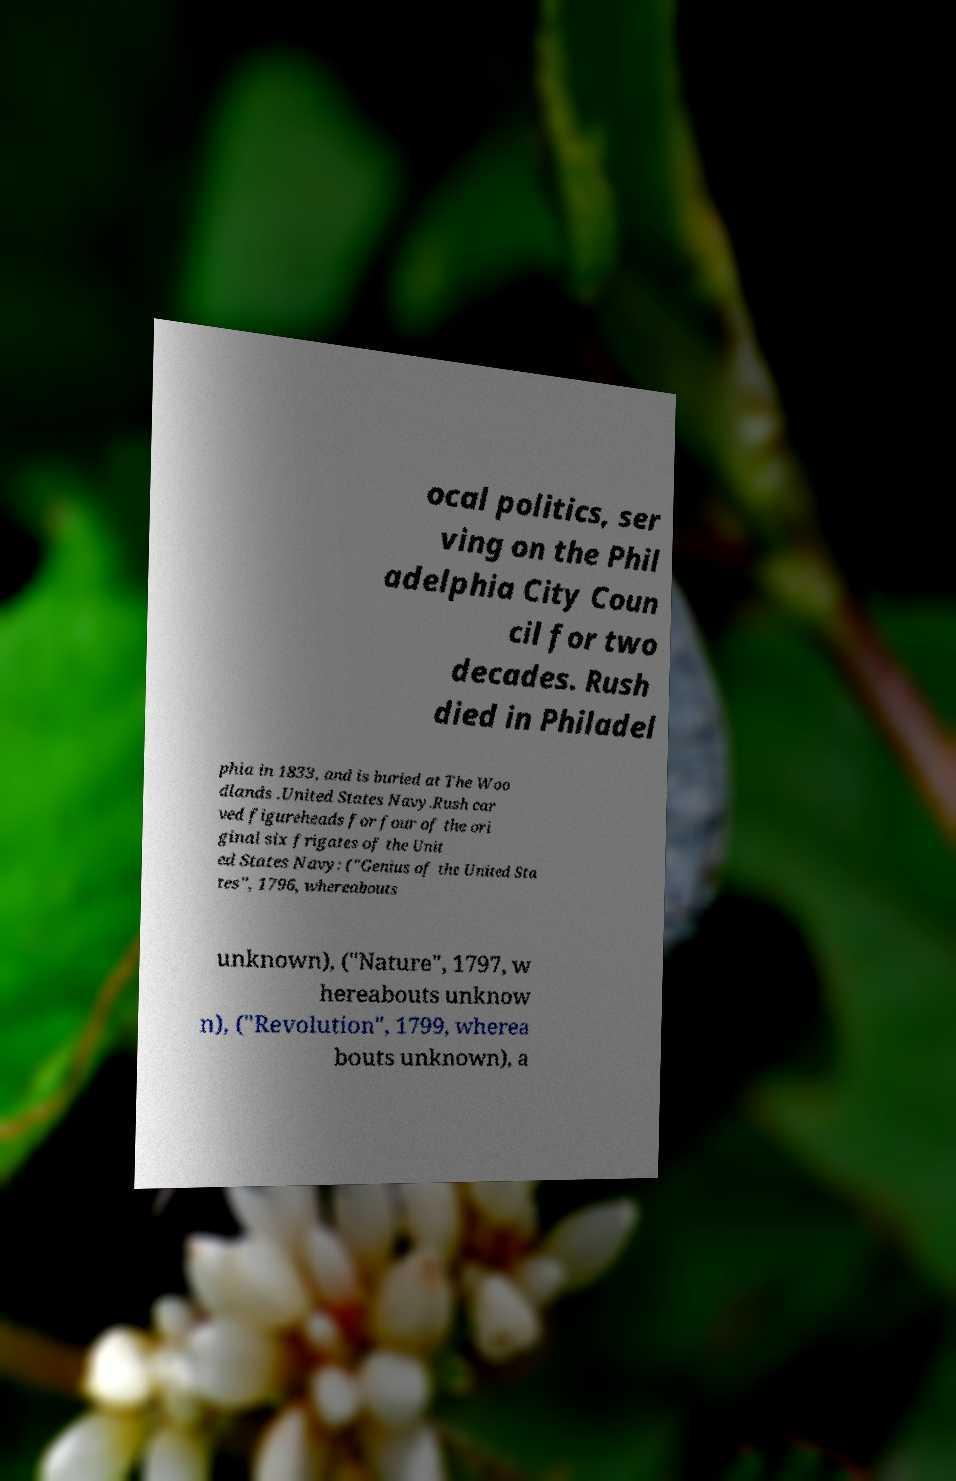Could you assist in decoding the text presented in this image and type it out clearly? ocal politics, ser ving on the Phil adelphia City Coun cil for two decades. Rush died in Philadel phia in 1833, and is buried at The Woo dlands .United States Navy.Rush car ved figureheads for four of the ori ginal six frigates of the Unit ed States Navy: ("Genius of the United Sta tes", 1796, whereabouts unknown), ("Nature", 1797, w hereabouts unknow n), ("Revolution", 1799, wherea bouts unknown), a 